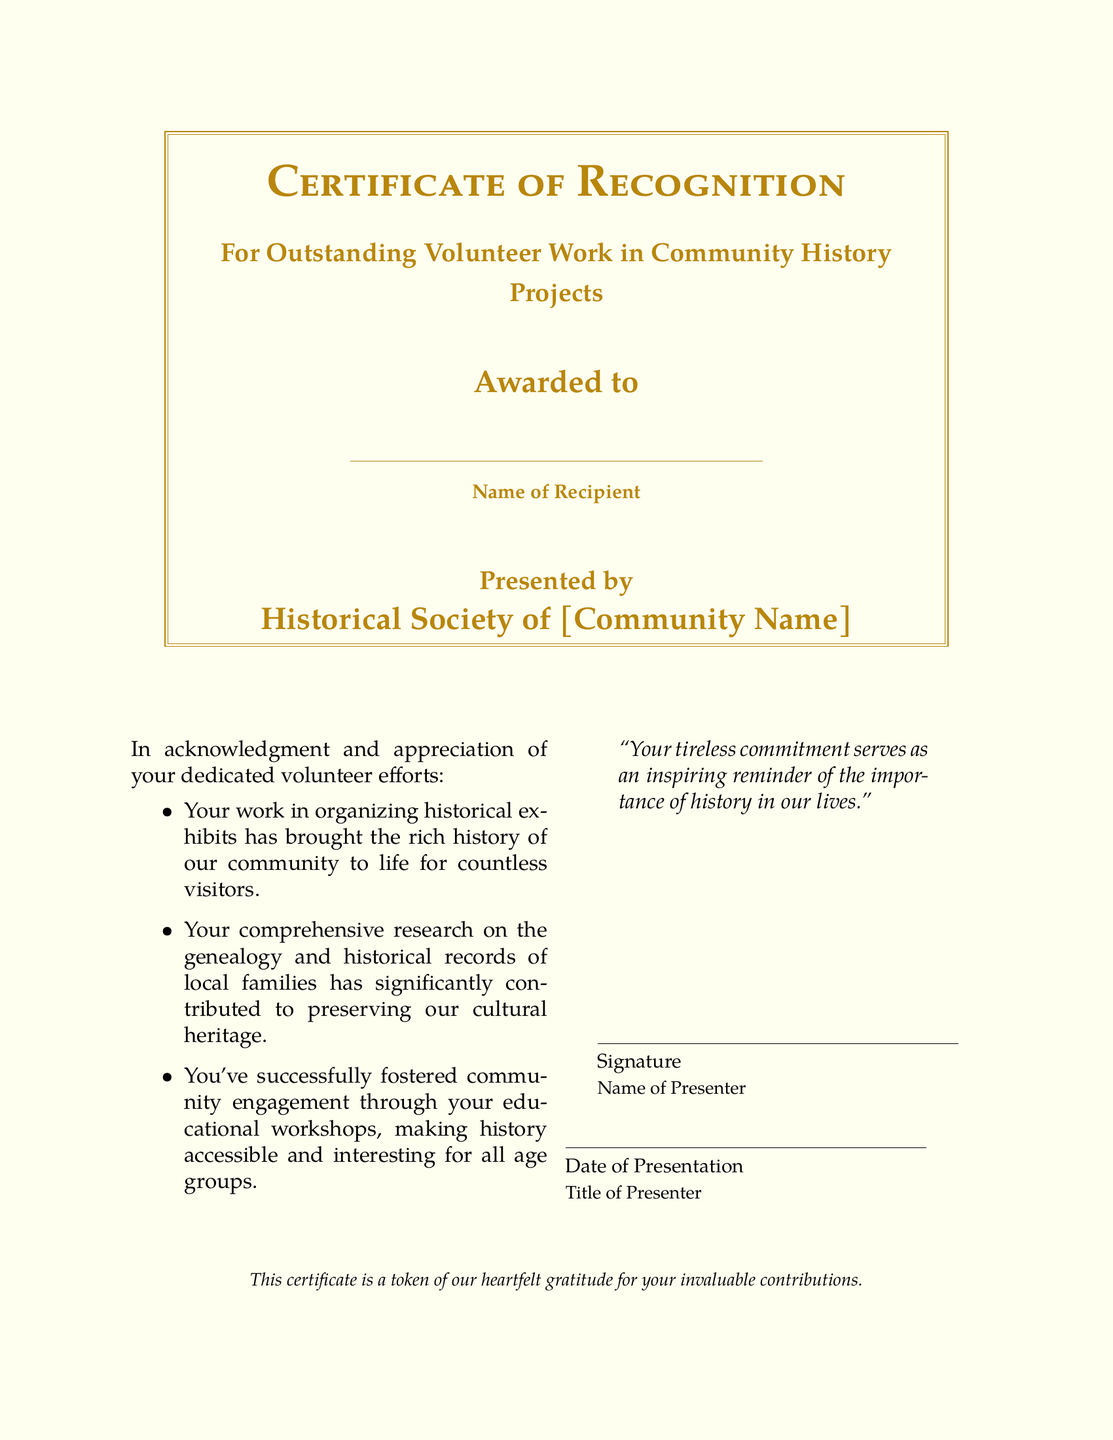what is the title of the certificate? The title of the certificate is prominently displayed at the top of the document, indicating the purpose of recognition.
Answer: Certificate of Recognition who is the certificate awarded to? The certificate includes a space for the recipient's name, indicating who the recognition is for.
Answer: Name of Recipient who presented the certificate? The certificate specifies the organization that is presenting the award.
Answer: Historical Society of [Community Name] what type of community engagement has the recipient fostered? The document lists activities that illustrate the type of community engagement that the recipient has supported.
Answer: Educational workshops what inspired the quote included in the document? The quote reflects the importance of the recipient's commitment to history and its relevance to society.
Answer: Tireless commitment how many main contributions are listed in the document? The document enumerates specific contributions made by the recipient to acknowledge their efforts.
Answer: Three what is the background color of the certificate? The color used for the page background is described in the document’s formatting.
Answer: Ivory what is the size of the certificate? The document specifies the paper size used for creating the certificate.
Answer: Letter paper 